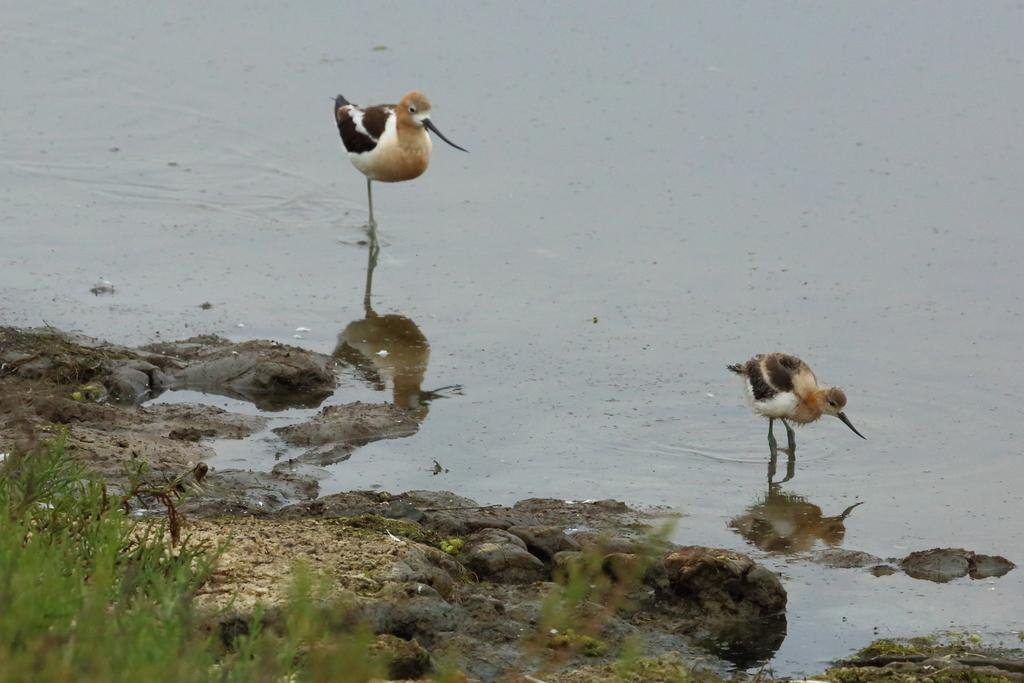How many birds are visible in the image? There are two birds in the image. Where are the birds located? The birds are on the water in the image. What other objects or features can be seen in the image? There is a rock and grass visible in the image. What type of jam is being spread on the grass in the image? There is no jam present in the image; it features two birds on the water, a rock, and grass. 